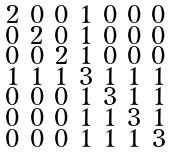<formula> <loc_0><loc_0><loc_500><loc_500>\begin{smallmatrix} 2 & 0 & 0 & 1 & 0 & 0 & 0 \\ 0 & 2 & 0 & 1 & 0 & 0 & 0 \\ 0 & 0 & 2 & 1 & 0 & 0 & 0 \\ 1 & 1 & 1 & 3 & 1 & 1 & 1 \\ 0 & 0 & 0 & 1 & 3 & 1 & 1 \\ 0 & 0 & 0 & 1 & 1 & 3 & 1 \\ 0 & 0 & 0 & 1 & 1 & 1 & 3 \end{smallmatrix}</formula> 